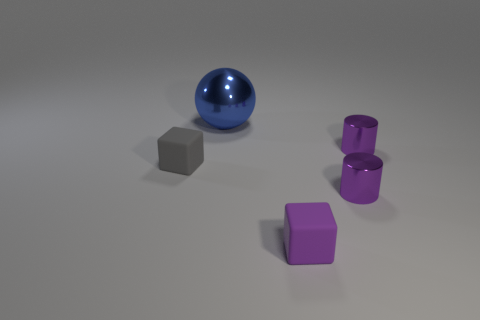Are there any other gray rubber objects of the same shape as the small gray matte object?
Make the answer very short. No. There is a purple matte object that is the same size as the gray matte thing; what shape is it?
Provide a short and direct response. Cube. What number of small blocks are the same color as the big object?
Provide a succinct answer. 0. How big is the block left of the big blue object?
Provide a succinct answer. Small. How many other blocks have the same size as the gray matte block?
Your answer should be very brief. 1. The small object that is the same material as the purple cube is what color?
Your answer should be very brief. Gray. Is the number of big blue objects behind the big blue metal sphere less than the number of small yellow rubber objects?
Offer a terse response. No. What is the shape of the other object that is the same material as the gray object?
Provide a short and direct response. Cube. How many rubber objects are either big spheres or purple things?
Give a very brief answer. 1. Is the number of gray things in front of the blue thing the same as the number of tiny metallic cylinders?
Provide a succinct answer. No. 